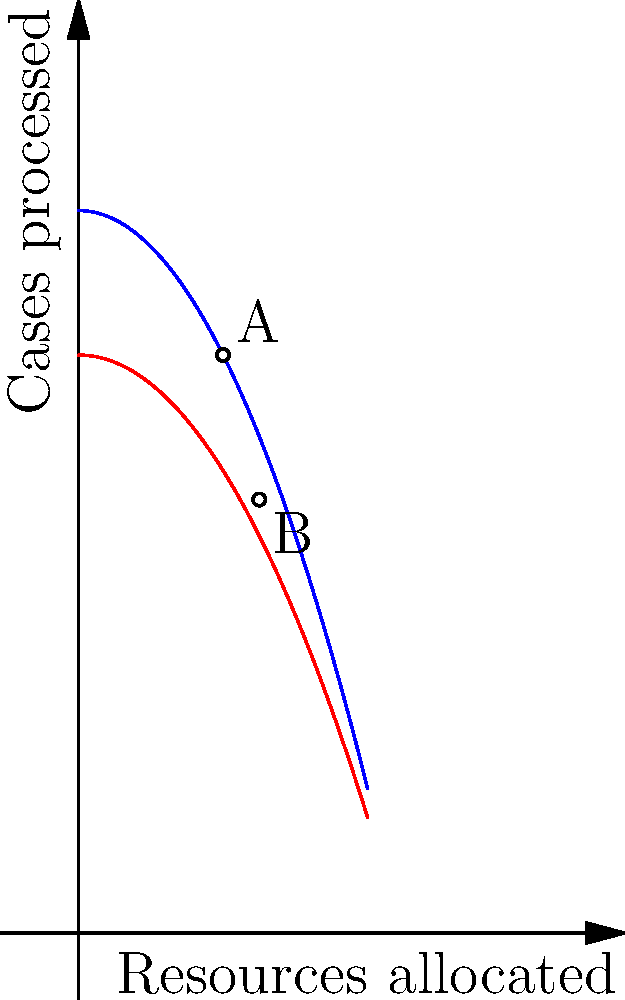The graph shows constraint curves for resource allocation between the International Criminal Court (ICC) and the International Court of Justice (ICJ). Point A represents the current allocation, while point B represents a proposed new allocation. If the total number of cases processed is to be maximized, which allocation point should be chosen, and why? To determine which allocation point maximizes the total number of cases processed, we need to follow these steps:

1. Identify the functions for each court:
   ICC: $f(x) = 100 - \frac{x^2}{20}$
   ICJ: $g(x) = 80 - \frac{x^2}{25}$

2. Calculate the total cases processed at point A (20, 80):
   ICC: $f(20) = 100 - \frac{20^2}{20} = 80$
   ICJ: $g(20) = 80 - \frac{20^2}{25} = 64$
   Total at A: $80 + 64 = 144$ cases

3. Calculate the total cases processed at point B (25, 60):
   ICC: $f(25) = 100 - \frac{25^2}{20} = 68.75$
   ICJ: $g(25) = 80 - \frac{25^2}{25} = 55$
   Total at B: $68.75 + 55 = 123.75$ cases

4. Compare the totals:
   Point A: 144 cases
   Point B: 123.75 cases

5. Conclusion: Point A maximizes the total number of cases processed.

The reason for this is that the constraint curves are not linear, but quadratic. The marginal return on resources decreases as more resources are allocated to either court. At point A, the balance of resources leads to a higher total output compared to point B, where the allocation is less efficient due to diminishing returns.
Answer: Point A (144 cases vs. 123.75 cases at B) 